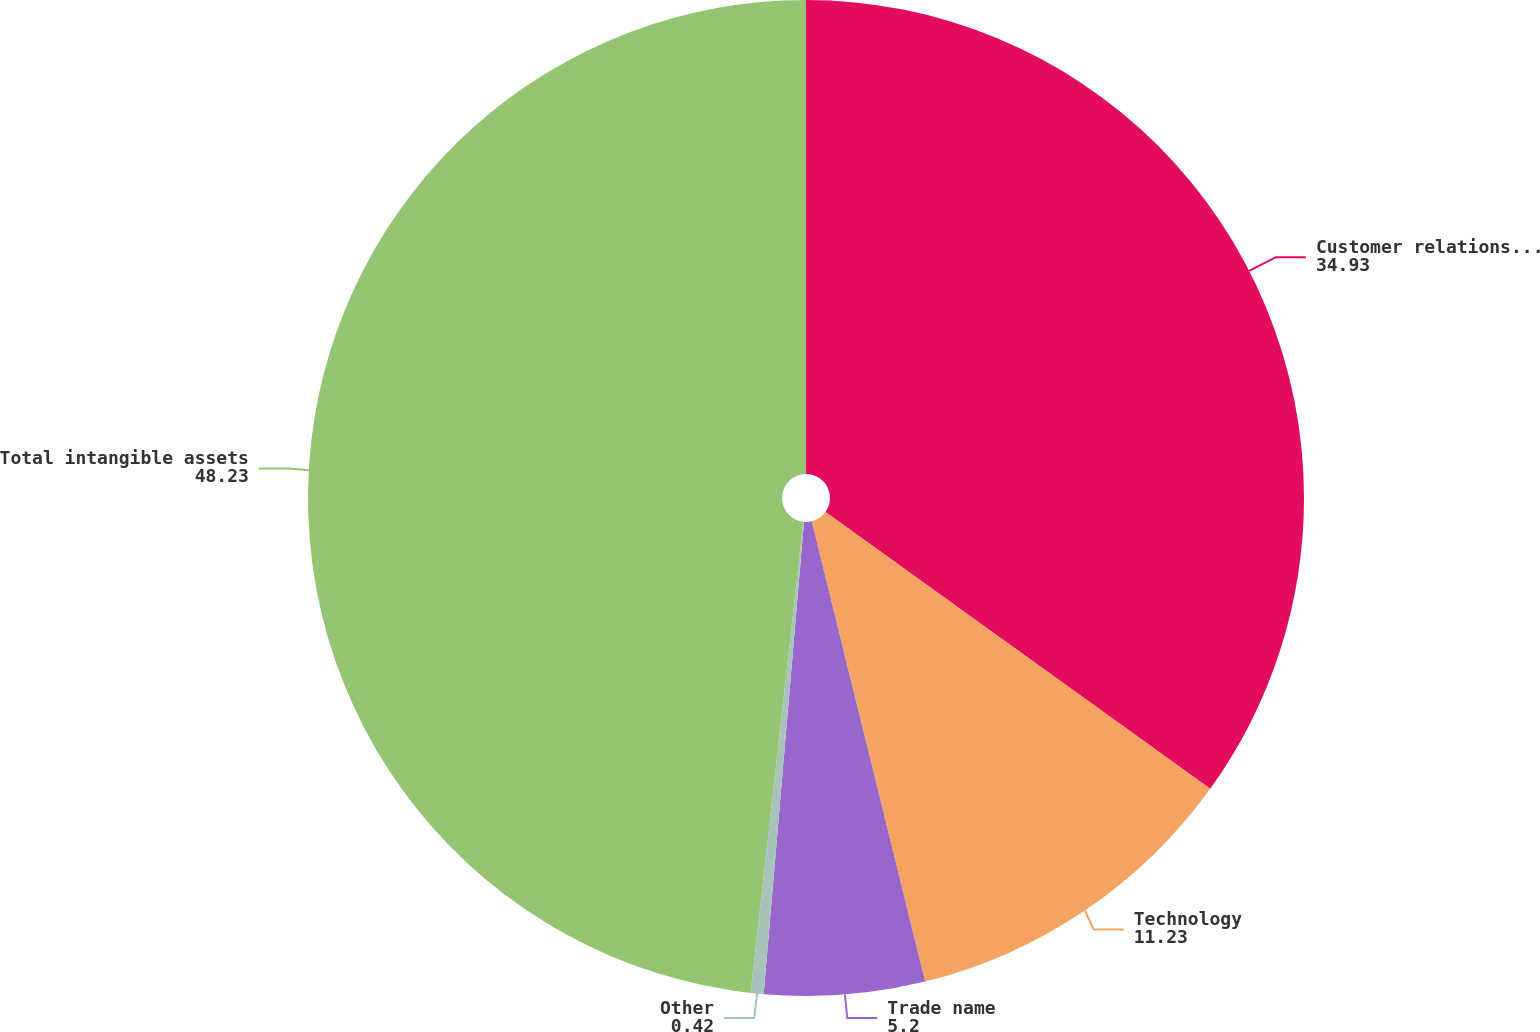<chart> <loc_0><loc_0><loc_500><loc_500><pie_chart><fcel>Customer relationships<fcel>Technology<fcel>Trade name<fcel>Other<fcel>Total intangible assets<nl><fcel>34.93%<fcel>11.23%<fcel>5.2%<fcel>0.42%<fcel>48.23%<nl></chart> 